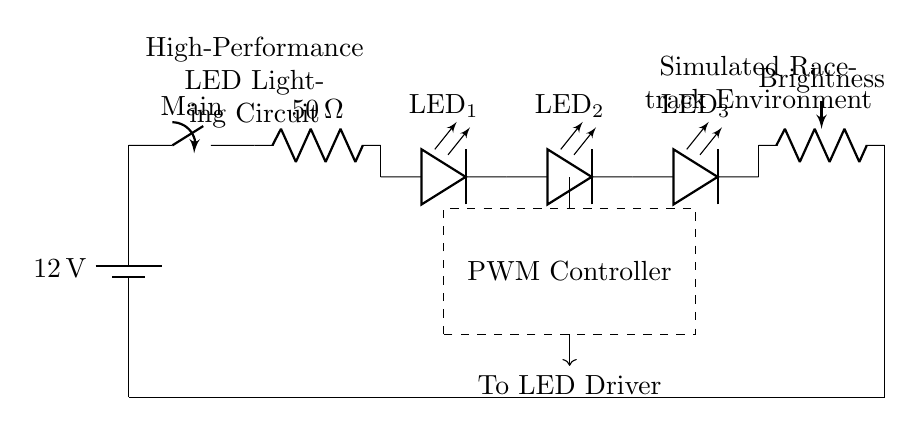What is the voltage of the power supply? The circuit shows a battery labeled with a voltage of 12 volts, indicating the potential difference provided by the power supply.
Answer: 12 volts What is the resistance value of the current limiting resistor? The circuit diagram indicates that the current limiting resistor is labeled with a value of 50 ohms, which is responsible for controlling the current flowing to the LEDs.
Answer: 50 ohms How many LEDs are in the circuit? Counting the components in the diagram, I can see three LEDs labeled as LED one, LED two, and LED three, which indicates the total is three.
Answer: Three What component is used for brightness control? The circuit includes a potentiometer labeled "Brightness," which is specifically designed to adjust the intensity of the LED lighting in the circuit.
Answer: Potentiometer What is the purpose of the PWM controller in this circuit? The PWM controller governs the brightness of the LEDs and modulates the power supplied, allowing for efficient control of the light output based on racing simulation needs.
Answer: Brightness modulation What is located below the PWM controller? Prior to the PWM controller, a connection labeled "To LED Driver" is present, indicating a control signal line that connects the PWM controller to the LED driving circuitry.
Answer: To LED Driver What does the dashed rectangle signify? The dashed rectangle in the circuit indicates the area where the PWM controller is situated, distinguishing it as a functional block in the overall circuit design.
Answer: PWM Controller 